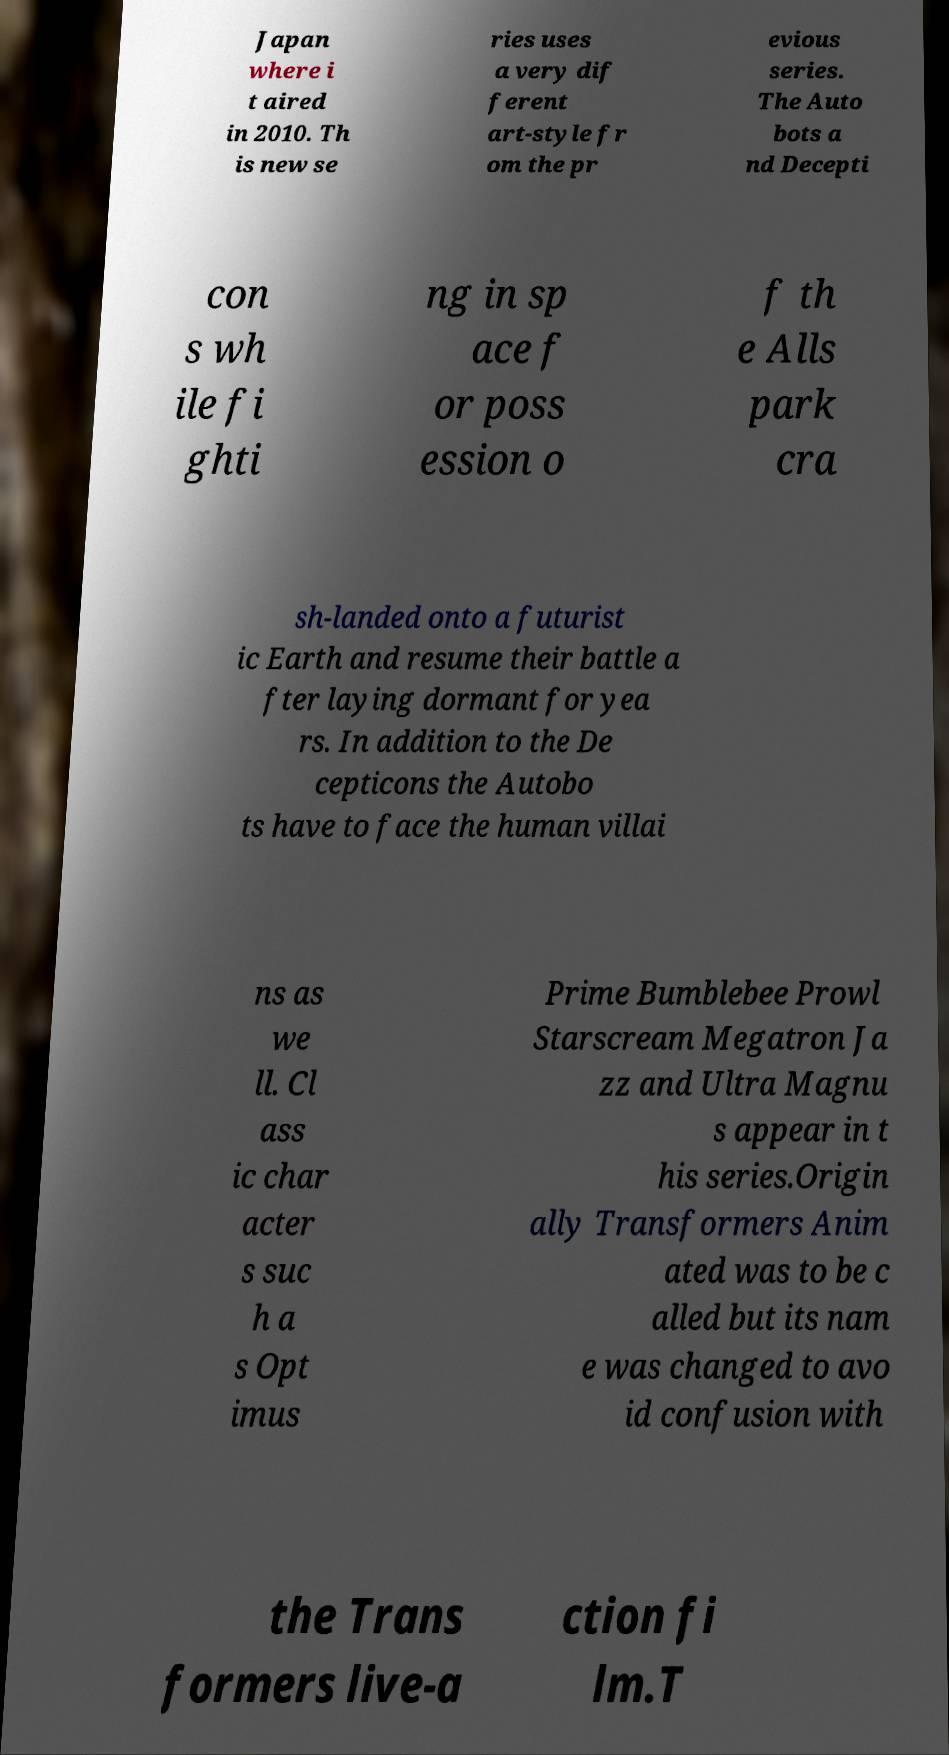I need the written content from this picture converted into text. Can you do that? Japan where i t aired in 2010. Th is new se ries uses a very dif ferent art-style fr om the pr evious series. The Auto bots a nd Decepti con s wh ile fi ghti ng in sp ace f or poss ession o f th e Alls park cra sh-landed onto a futurist ic Earth and resume their battle a fter laying dormant for yea rs. In addition to the De cepticons the Autobo ts have to face the human villai ns as we ll. Cl ass ic char acter s suc h a s Opt imus Prime Bumblebee Prowl Starscream Megatron Ja zz and Ultra Magnu s appear in t his series.Origin ally Transformers Anim ated was to be c alled but its nam e was changed to avo id confusion with the Trans formers live-a ction fi lm.T 